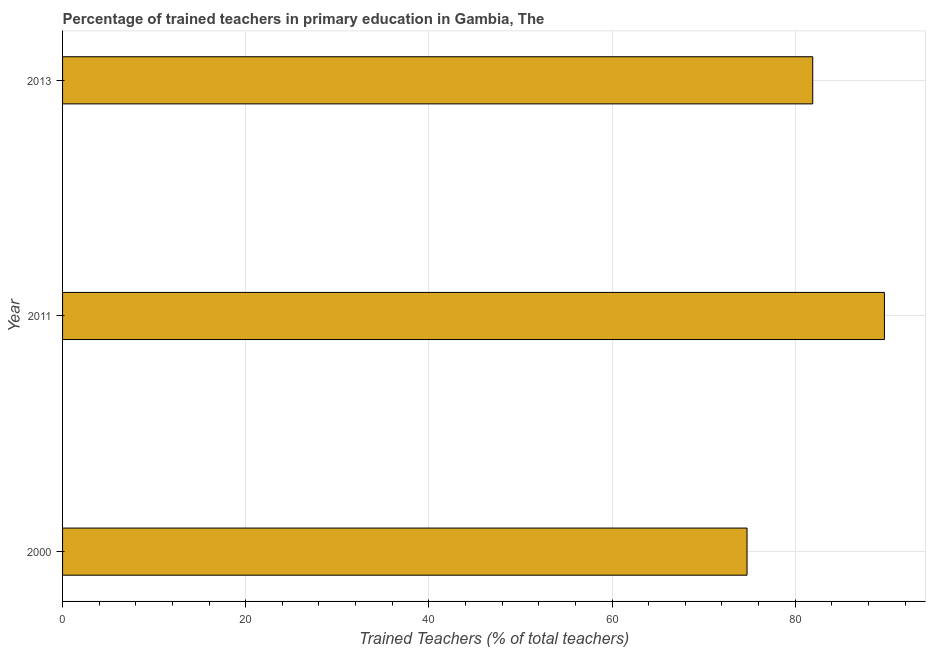Does the graph contain any zero values?
Your answer should be compact. No. Does the graph contain grids?
Your answer should be very brief. Yes. What is the title of the graph?
Keep it short and to the point. Percentage of trained teachers in primary education in Gambia, The. What is the label or title of the X-axis?
Provide a succinct answer. Trained Teachers (% of total teachers). What is the percentage of trained teachers in 2013?
Your answer should be very brief. 81.92. Across all years, what is the maximum percentage of trained teachers?
Your response must be concise. 89.74. Across all years, what is the minimum percentage of trained teachers?
Offer a very short reply. 74.74. What is the sum of the percentage of trained teachers?
Offer a very short reply. 246.4. What is the average percentage of trained teachers per year?
Give a very brief answer. 82.13. What is the median percentage of trained teachers?
Your answer should be very brief. 81.92. What is the ratio of the percentage of trained teachers in 2000 to that in 2011?
Offer a very short reply. 0.83. Is the percentage of trained teachers in 2000 less than that in 2011?
Keep it short and to the point. Yes. Is the difference between the percentage of trained teachers in 2000 and 2011 greater than the difference between any two years?
Ensure brevity in your answer.  Yes. What is the difference between the highest and the second highest percentage of trained teachers?
Your answer should be very brief. 7.83. Is the sum of the percentage of trained teachers in 2011 and 2013 greater than the maximum percentage of trained teachers across all years?
Your answer should be compact. Yes. What is the difference between the highest and the lowest percentage of trained teachers?
Give a very brief answer. 15. Are all the bars in the graph horizontal?
Keep it short and to the point. Yes. How many years are there in the graph?
Offer a very short reply. 3. What is the Trained Teachers (% of total teachers) in 2000?
Provide a short and direct response. 74.74. What is the Trained Teachers (% of total teachers) in 2011?
Provide a short and direct response. 89.74. What is the Trained Teachers (% of total teachers) in 2013?
Give a very brief answer. 81.92. What is the difference between the Trained Teachers (% of total teachers) in 2000 and 2011?
Make the answer very short. -15. What is the difference between the Trained Teachers (% of total teachers) in 2000 and 2013?
Your answer should be very brief. -7.17. What is the difference between the Trained Teachers (% of total teachers) in 2011 and 2013?
Make the answer very short. 7.83. What is the ratio of the Trained Teachers (% of total teachers) in 2000 to that in 2011?
Offer a very short reply. 0.83. What is the ratio of the Trained Teachers (% of total teachers) in 2000 to that in 2013?
Your answer should be very brief. 0.91. What is the ratio of the Trained Teachers (% of total teachers) in 2011 to that in 2013?
Provide a short and direct response. 1.1. 